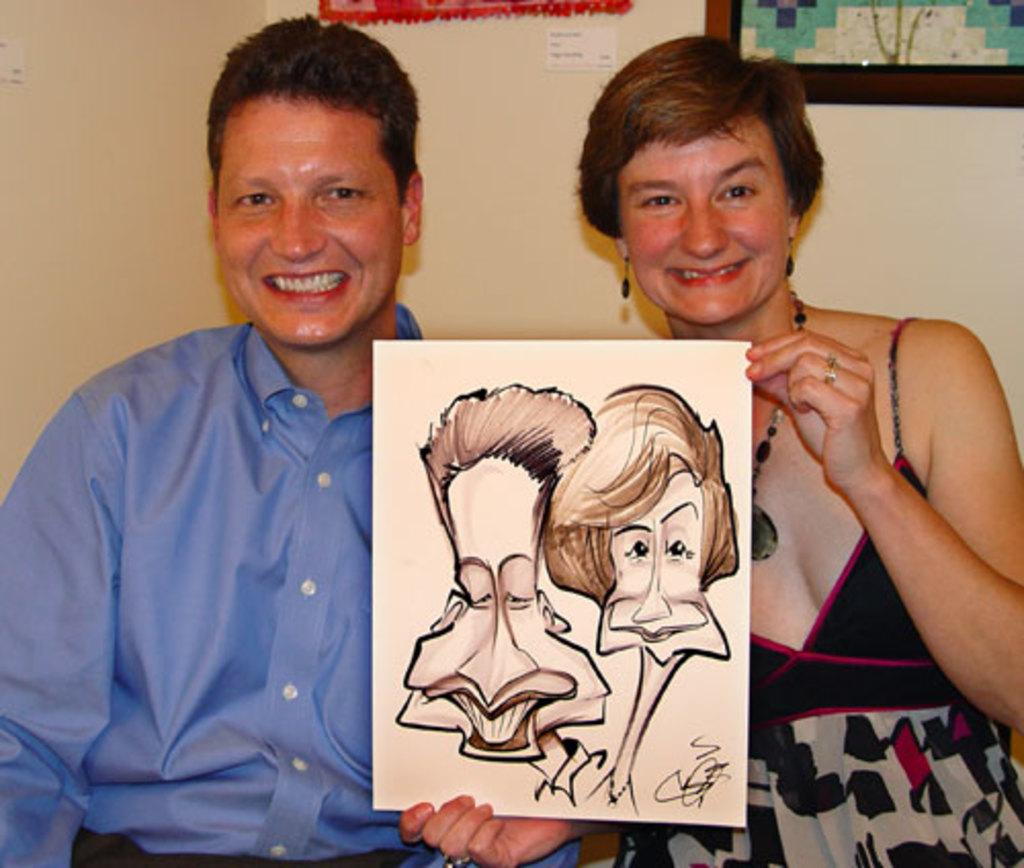What is the man in the image wearing? The man in the image is wearing a blue shirt. What is the woman in the image wearing? The woman in the image is wearing a black dress. What is the woman holding in the image? The woman is holding a painting. Where is the painting located in the image? There is a wall with a painting in the image. How are the man and woman positioned in relation to each other? The man is standing beside the woman. What type of lumber is being used to create a volleyball net in the image? There is no volleyball net or lumber present in the image. How many snails can be seen crawling on the painting in the image? There are no snails visible on the painting in the image. 